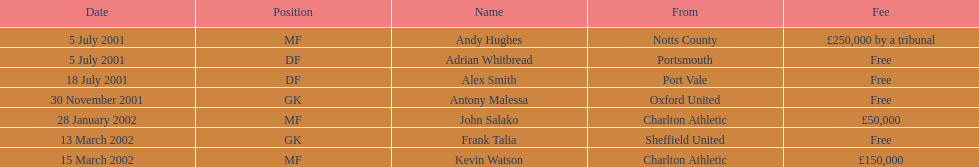Which player had the highest transfer fee, andy hughes or john salako? Andy Hughes. 